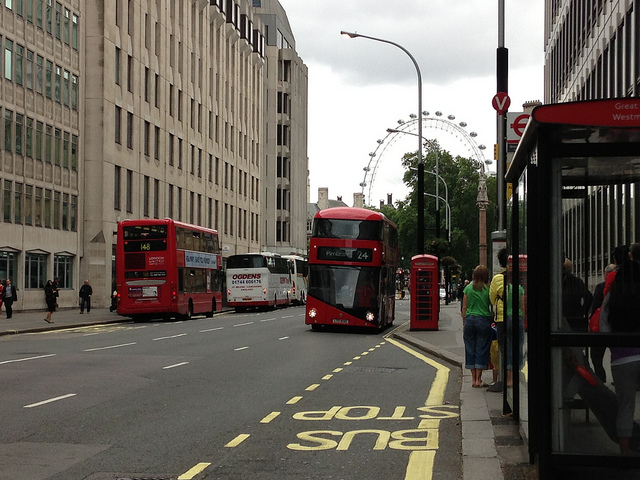Read and extract the text from this image. 24 OADENS 145 BUS STOP V Grea 